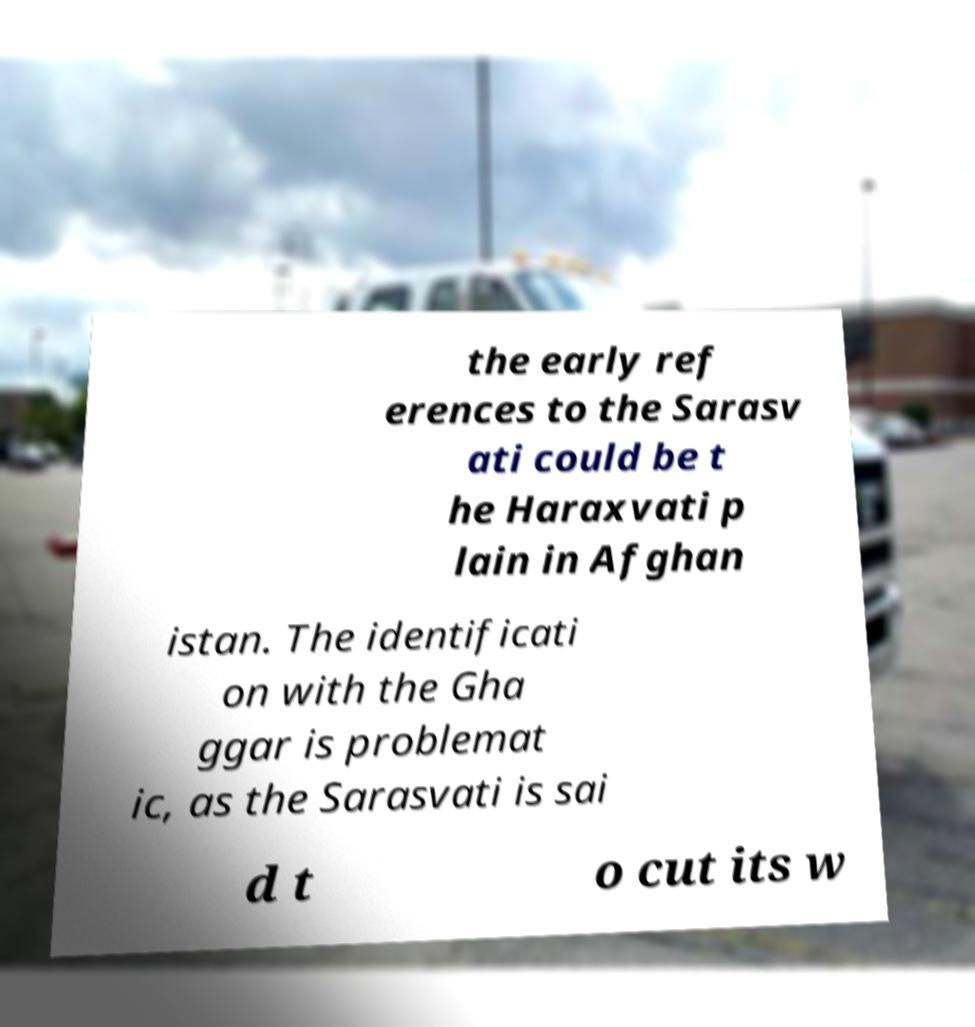Can you read and provide the text displayed in the image?This photo seems to have some interesting text. Can you extract and type it out for me? the early ref erences to the Sarasv ati could be t he Haraxvati p lain in Afghan istan. The identificati on with the Gha ggar is problemat ic, as the Sarasvati is sai d t o cut its w 